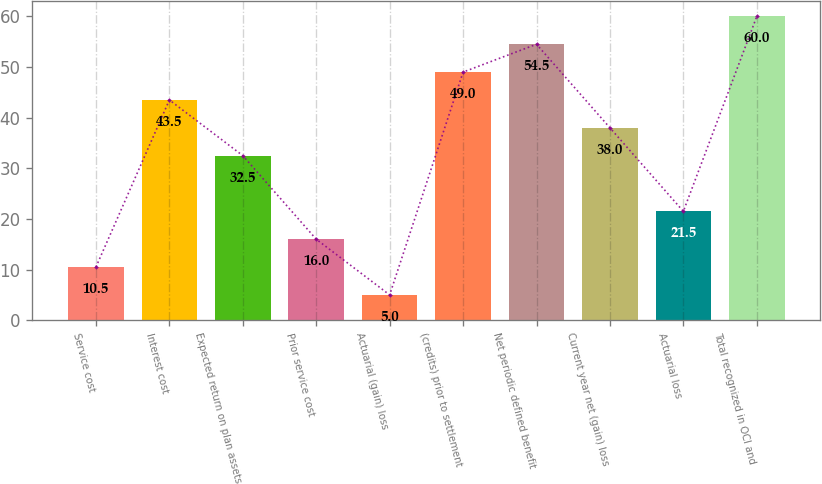<chart> <loc_0><loc_0><loc_500><loc_500><bar_chart><fcel>Service cost<fcel>Interest cost<fcel>Expected return on plan assets<fcel>Prior service cost<fcel>Actuarial (gain) loss<fcel>(credits) prior to settlement<fcel>Net periodic defined benefit<fcel>Current year net (gain) loss<fcel>Actuarial loss<fcel>Total recognized in OCI and<nl><fcel>10.5<fcel>43.5<fcel>32.5<fcel>16<fcel>5<fcel>49<fcel>54.5<fcel>38<fcel>21.5<fcel>60<nl></chart> 